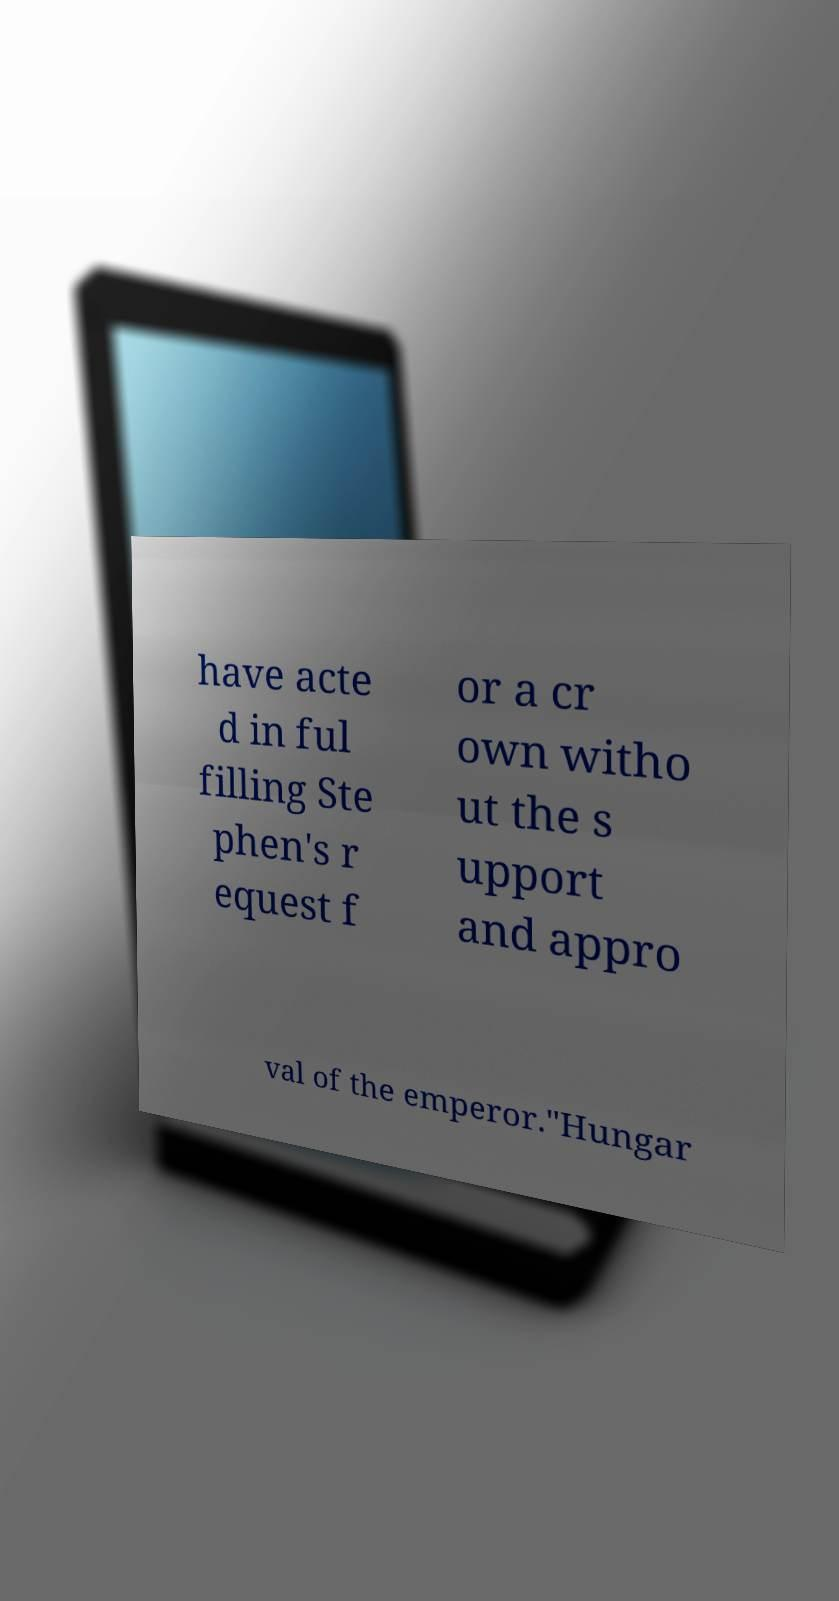I need the written content from this picture converted into text. Can you do that? have acte d in ful filling Ste phen's r equest f or a cr own witho ut the s upport and appro val of the emperor."Hungar 